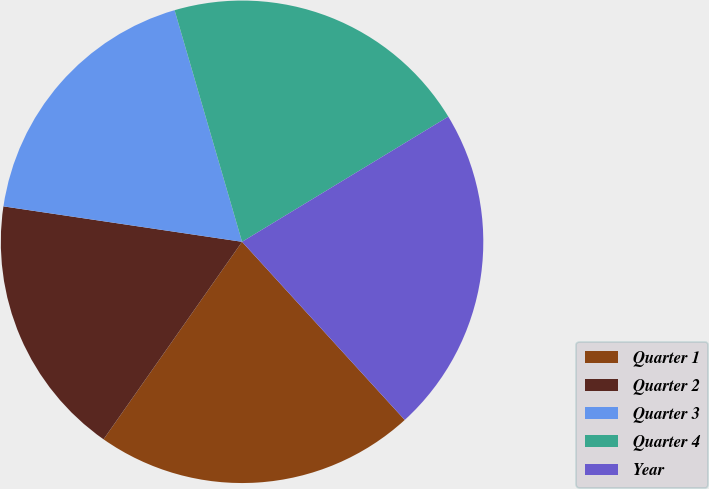Convert chart. <chart><loc_0><loc_0><loc_500><loc_500><pie_chart><fcel>Quarter 1<fcel>Quarter 2<fcel>Quarter 3<fcel>Quarter 4<fcel>Year<nl><fcel>21.51%<fcel>17.61%<fcel>18.14%<fcel>20.83%<fcel>21.9%<nl></chart> 